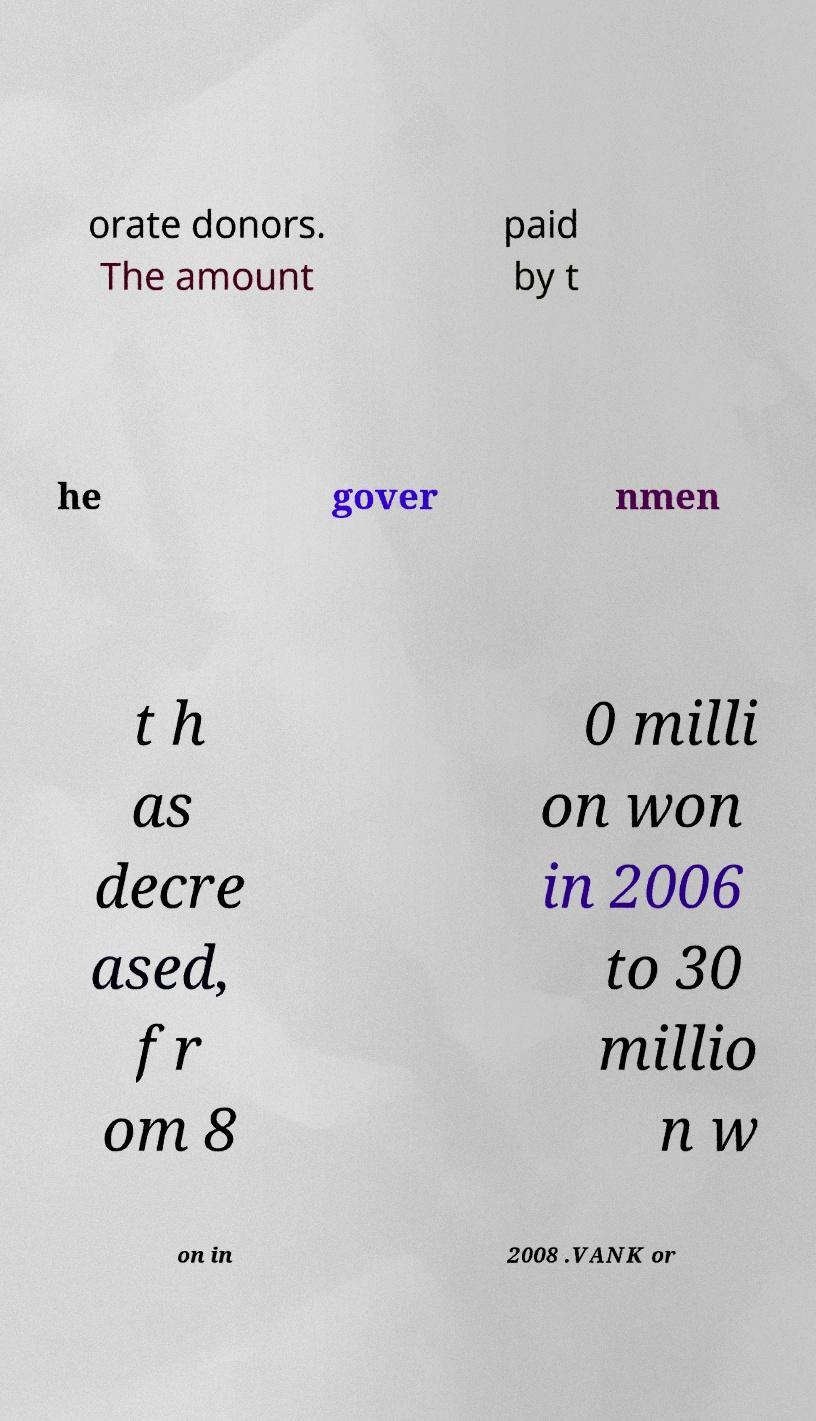There's text embedded in this image that I need extracted. Can you transcribe it verbatim? orate donors. The amount paid by t he gover nmen t h as decre ased, fr om 8 0 milli on won in 2006 to 30 millio n w on in 2008 .VANK or 